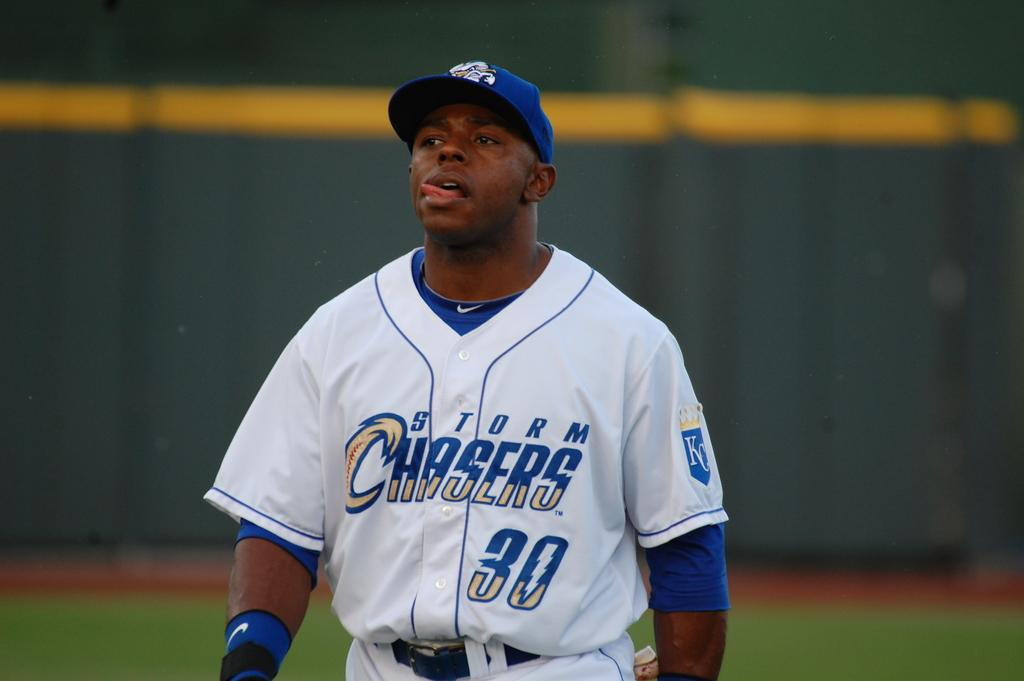<image>
Render a clear and concise summary of the photo. Man wearing a baseball jersey which says Chasers on it. 